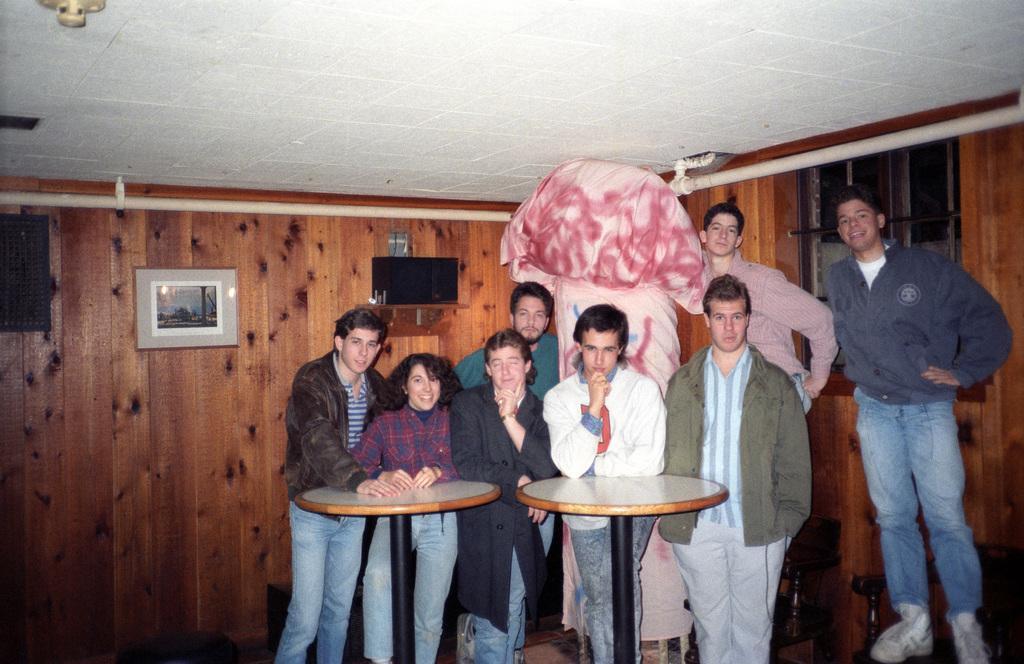Can you describe this image briefly? In this picture there are seven men and one lady are standing. In front of them there are two tables. In the background there is a frame and a speaker on the top. lady wearing a checked shirt and all others are wearing jackets. And to the right side there is a window. 